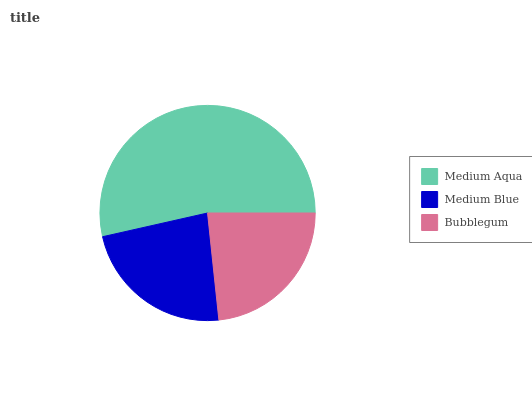Is Medium Blue the minimum?
Answer yes or no. Yes. Is Medium Aqua the maximum?
Answer yes or no. Yes. Is Bubblegum the minimum?
Answer yes or no. No. Is Bubblegum the maximum?
Answer yes or no. No. Is Bubblegum greater than Medium Blue?
Answer yes or no. Yes. Is Medium Blue less than Bubblegum?
Answer yes or no. Yes. Is Medium Blue greater than Bubblegum?
Answer yes or no. No. Is Bubblegum less than Medium Blue?
Answer yes or no. No. Is Bubblegum the high median?
Answer yes or no. Yes. Is Bubblegum the low median?
Answer yes or no. Yes. Is Medium Blue the high median?
Answer yes or no. No. Is Medium Blue the low median?
Answer yes or no. No. 